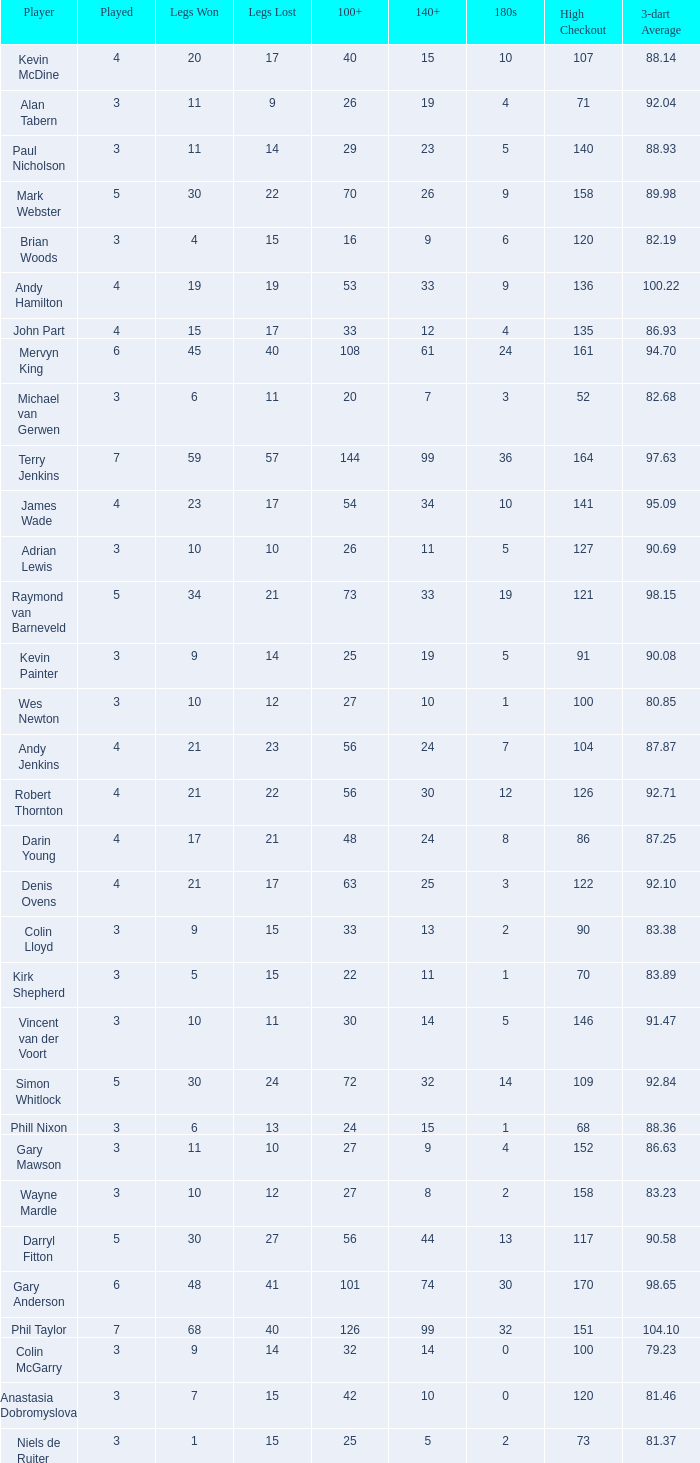What is the played number when the high checkout is 135? 4.0. 